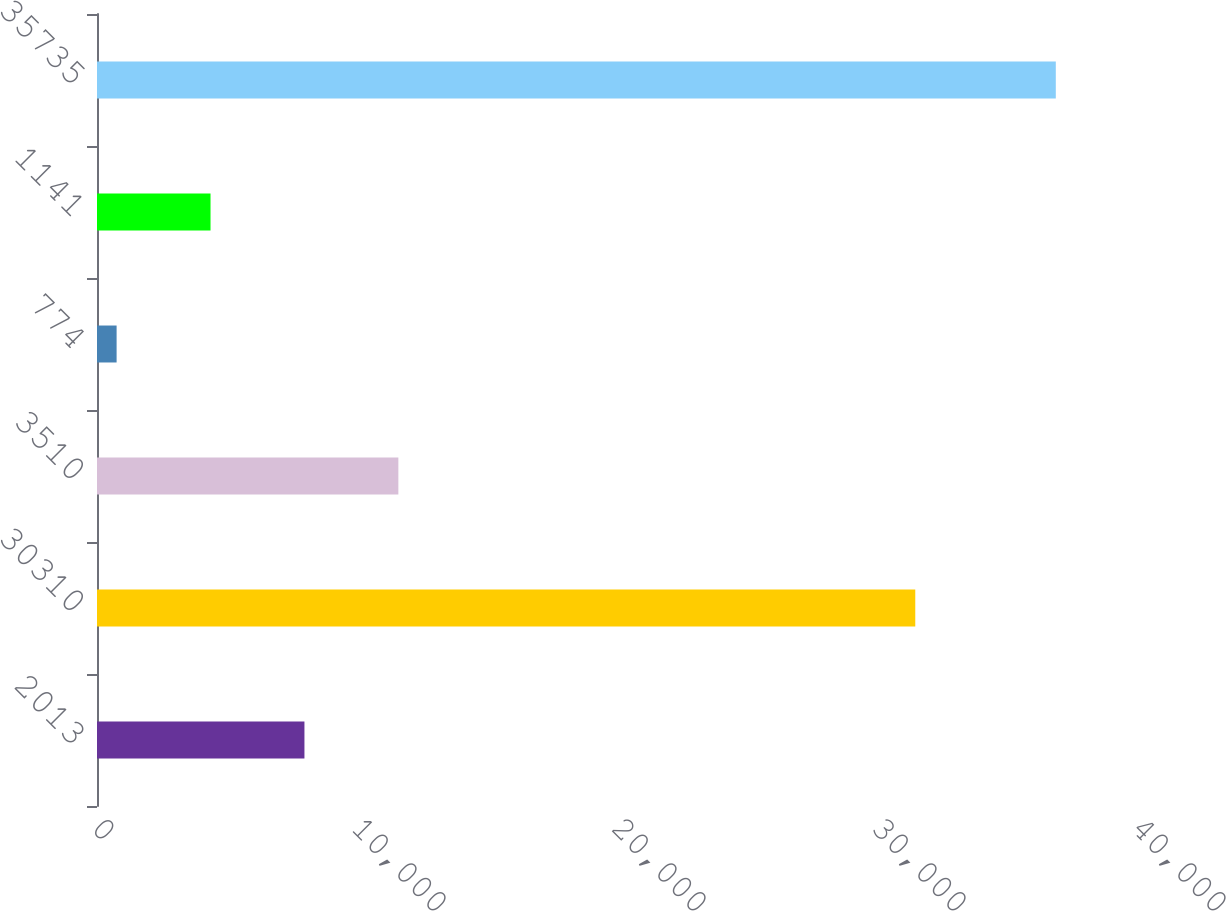<chart> <loc_0><loc_0><loc_500><loc_500><bar_chart><fcel>2013<fcel>30310<fcel>3510<fcel>774<fcel>1141<fcel>35735<nl><fcel>7978.6<fcel>31472<fcel>11590.9<fcel>754<fcel>4366.3<fcel>36877<nl></chart> 